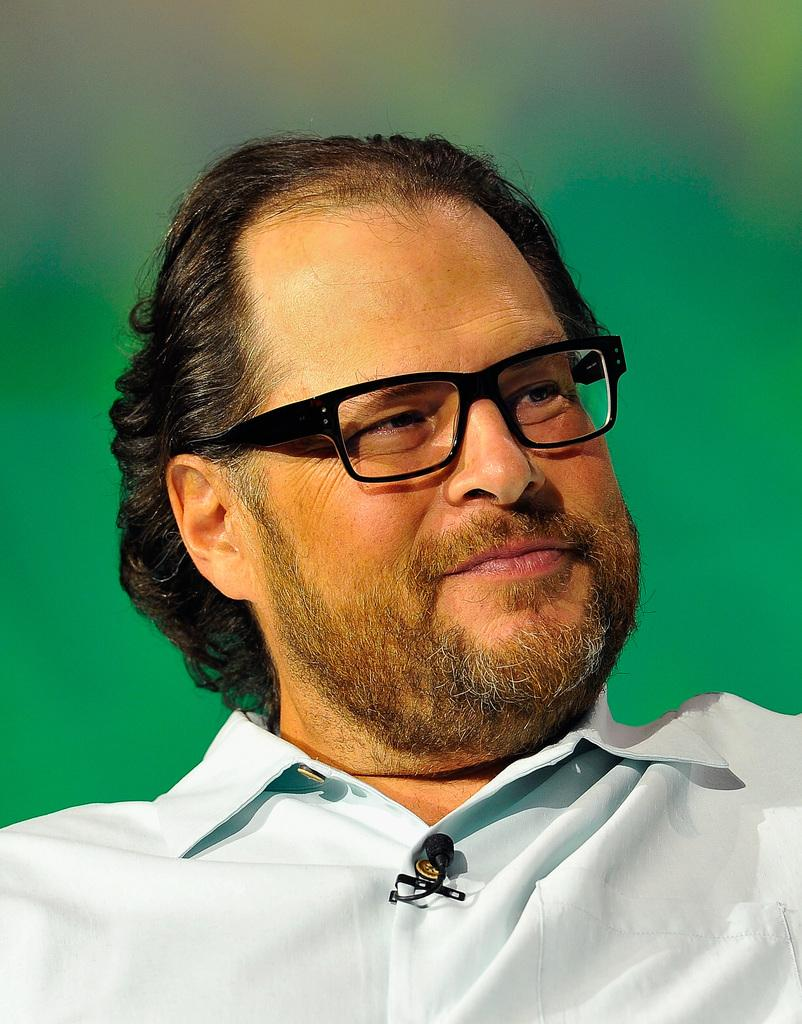What is the main subject of the image? There is a person in the image. Can you describe the person's appearance? The person is wearing spectacles. What type of rod can be seen in the person's hand in the image? There is no rod present in the image; the person is only wearing spectacles. 